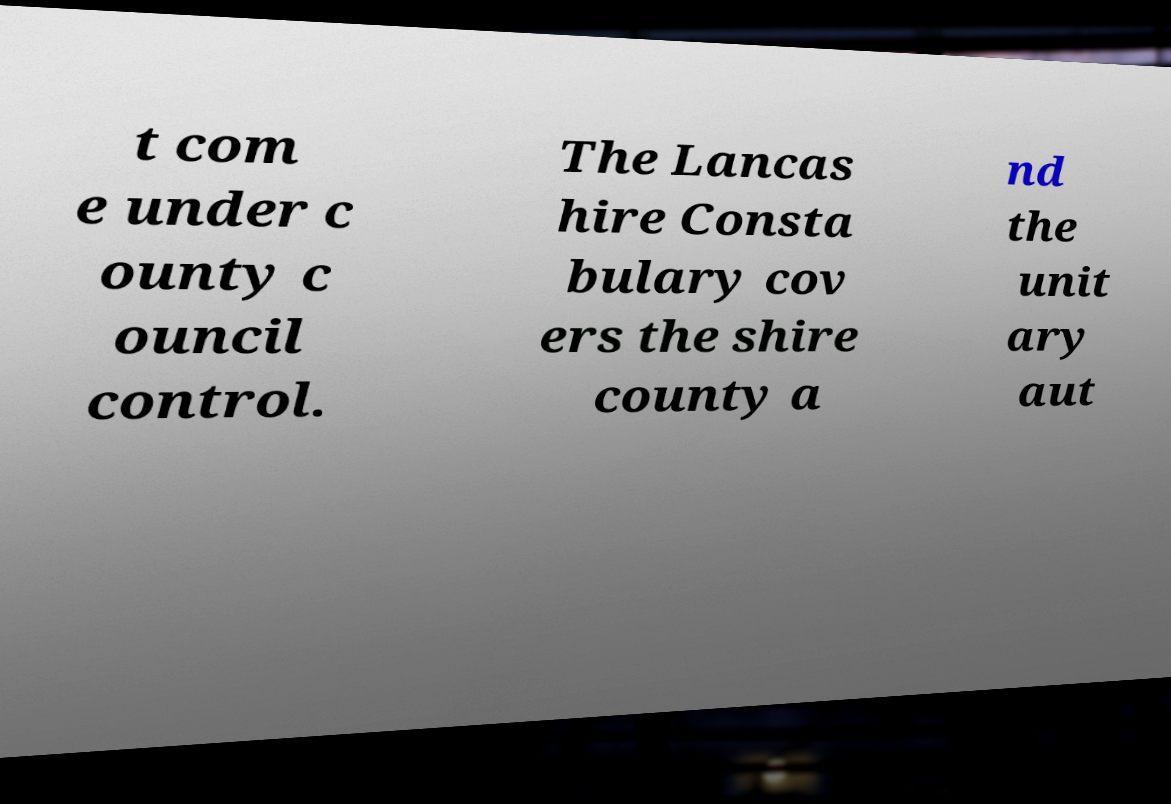Can you read and provide the text displayed in the image?This photo seems to have some interesting text. Can you extract and type it out for me? t com e under c ounty c ouncil control. The Lancas hire Consta bulary cov ers the shire county a nd the unit ary aut 